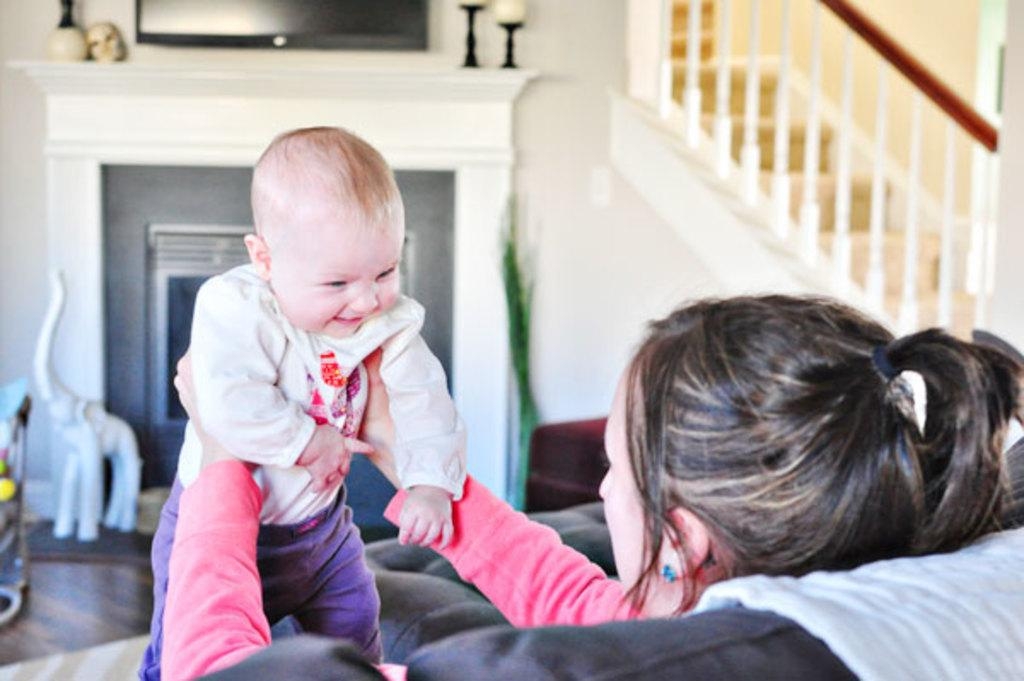What is the woman in the image doing? The woman is sitting on a couch and holding a baby. What can be seen in the background of the image? There is a sculpture and candles in the background. What architectural feature is visible on the right side of the image? There are stairs and a railing on the right side of the image. What is the woman's digestion like after eating a large meal in the image? There is no information about the woman's digestion or eating habits in the image. 